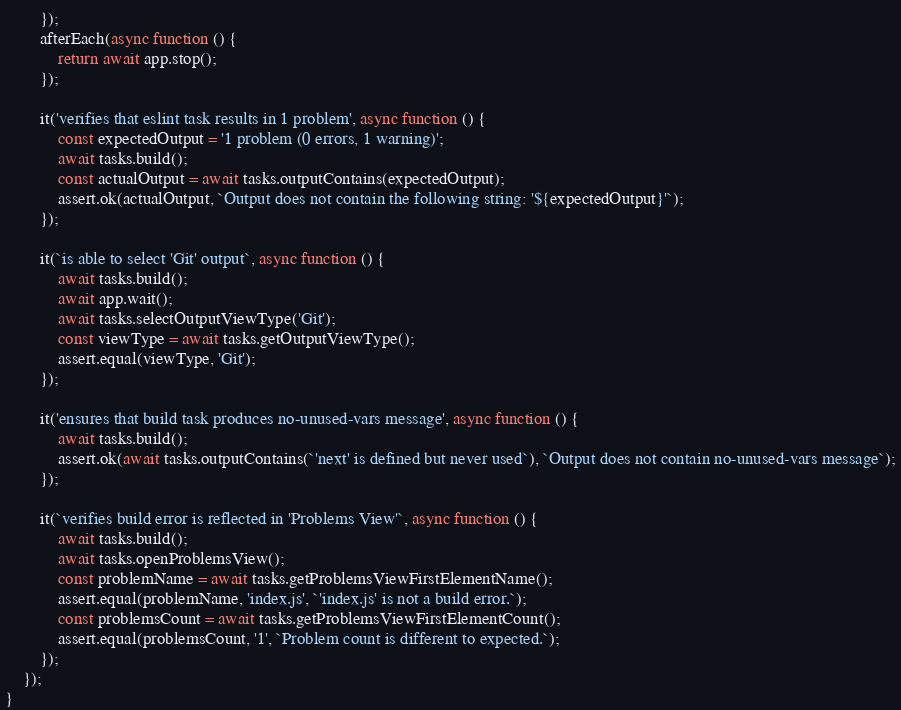<code> <loc_0><loc_0><loc_500><loc_500><_TypeScript_>		});
		afterEach(async function () {
			return await app.stop();
		});

		it('verifies that eslint task results in 1 problem', async function () {
			const expectedOutput = '1 problem (0 errors, 1 warning)';
			await tasks.build();
			const actualOutput = await tasks.outputContains(expectedOutput);
			assert.ok(actualOutput, `Output does not contain the following string: '${expectedOutput}'`);
		});

		it(`is able to select 'Git' output`, async function () {
			await tasks.build();
			await app.wait();
			await tasks.selectOutputViewType('Git');
			const viewType = await tasks.getOutputViewType();
			assert.equal(viewType, 'Git');
		});

		it('ensures that build task produces no-unused-vars message', async function () {
			await tasks.build();
			assert.ok(await tasks.outputContains(`'next' is defined but never used`), `Output does not contain no-unused-vars message`);
		});

		it(`verifies build error is reflected in 'Problems View'`, async function () {
			await tasks.build();
			await tasks.openProblemsView();
			const problemName = await tasks.getProblemsViewFirstElementName();
			assert.equal(problemName, 'index.js', `'index.js' is not a build error.`);
			const problemsCount = await tasks.getProblemsViewFirstElementCount();
			assert.equal(problemsCount, '1', `Problem count is different to expected.`);
		});
	});
}</code> 